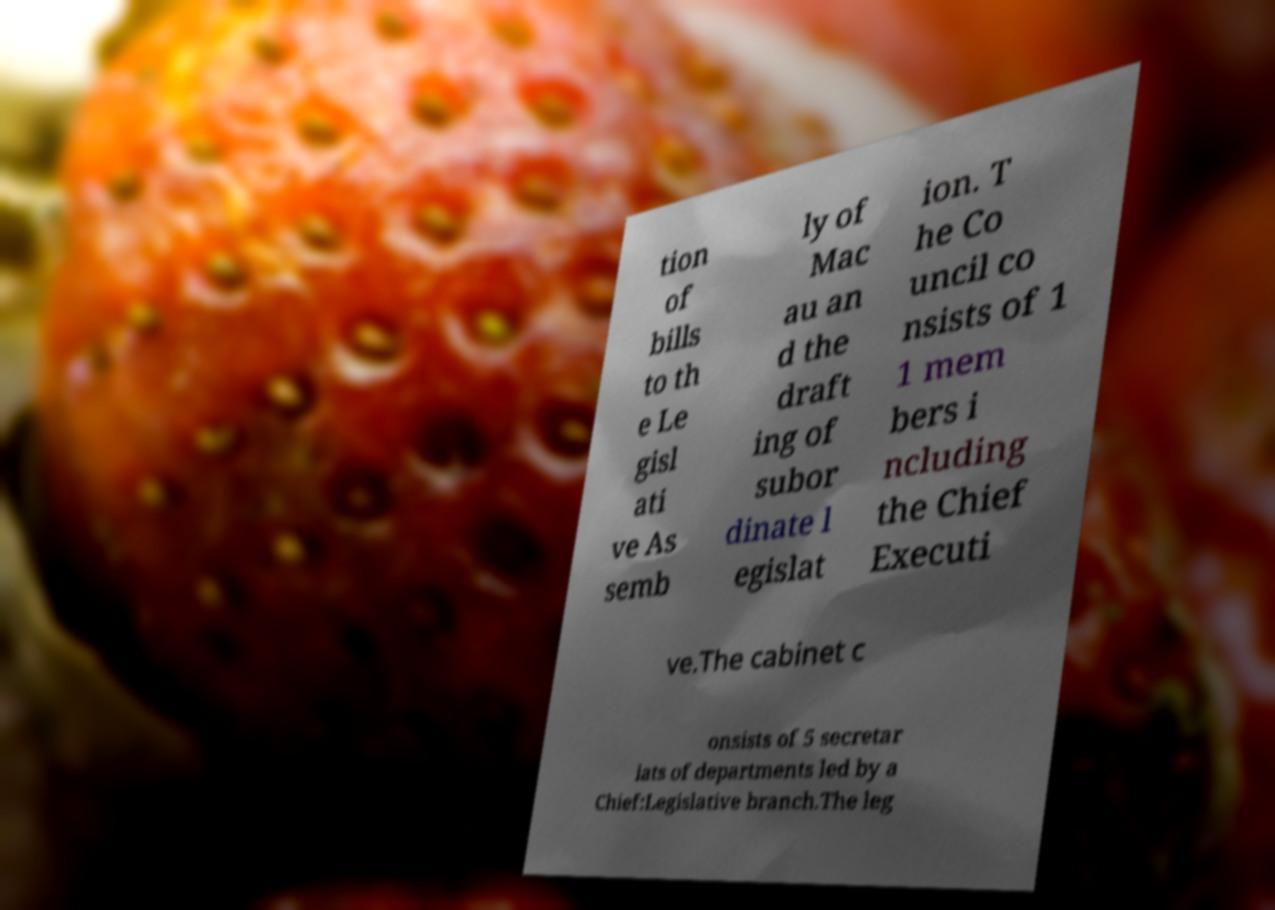I need the written content from this picture converted into text. Can you do that? tion of bills to th e Le gisl ati ve As semb ly of Mac au an d the draft ing of subor dinate l egislat ion. T he Co uncil co nsists of 1 1 mem bers i ncluding the Chief Executi ve.The cabinet c onsists of 5 secretar iats of departments led by a Chief:Legislative branch.The leg 